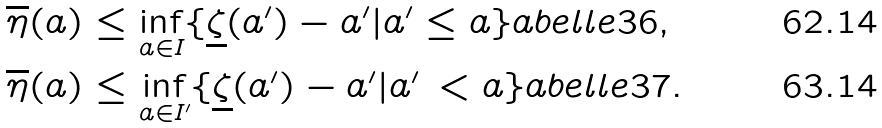<formula> <loc_0><loc_0><loc_500><loc_500>\overline { \eta } ( a ) & \leq \inf _ { a \in I } \{ \underline { \zeta } ( a ^ { \prime } ) - a ^ { \prime } | a ^ { \prime } \leq a \} \L a b e l { l e 3 6 } , \\ \overline { \eta } ( a ) & \leq \inf _ { a \in I ^ { \prime } } \{ \underline { \zeta } ( a ^ { \prime } ) - a ^ { \prime } | a ^ { \prime } \, < a \} \L a b e l { l e 3 7 } .</formula> 